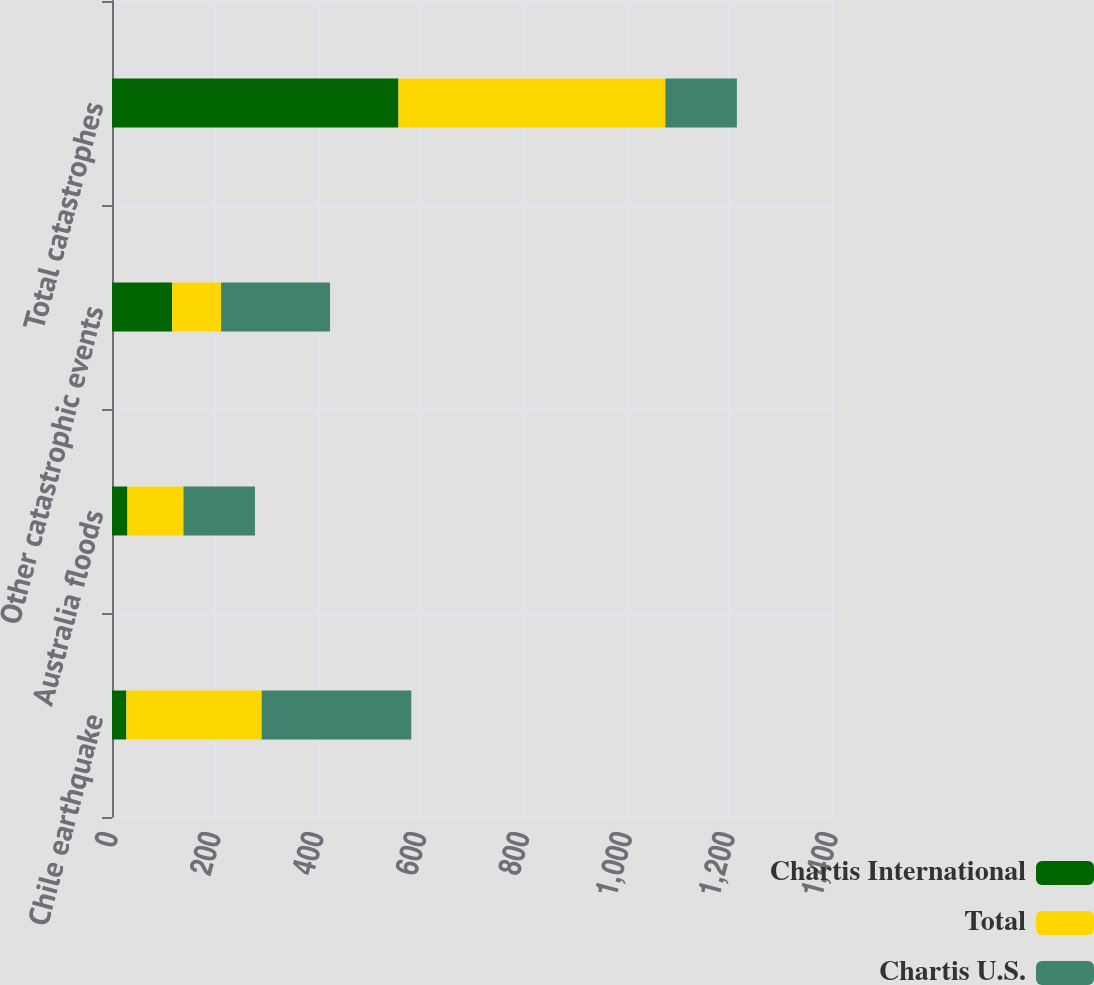Convert chart to OTSL. <chart><loc_0><loc_0><loc_500><loc_500><stacked_bar_chart><ecel><fcel>Chile earthquake<fcel>Australia floods<fcel>Other catastrophic events<fcel>Total catastrophes<nl><fcel>Chartis International<fcel>28<fcel>30<fcel>117<fcel>557<nl><fcel>Total<fcel>263<fcel>109<fcel>95<fcel>519<nl><fcel>Chartis U.S.<fcel>291<fcel>139<fcel>212<fcel>139<nl></chart> 